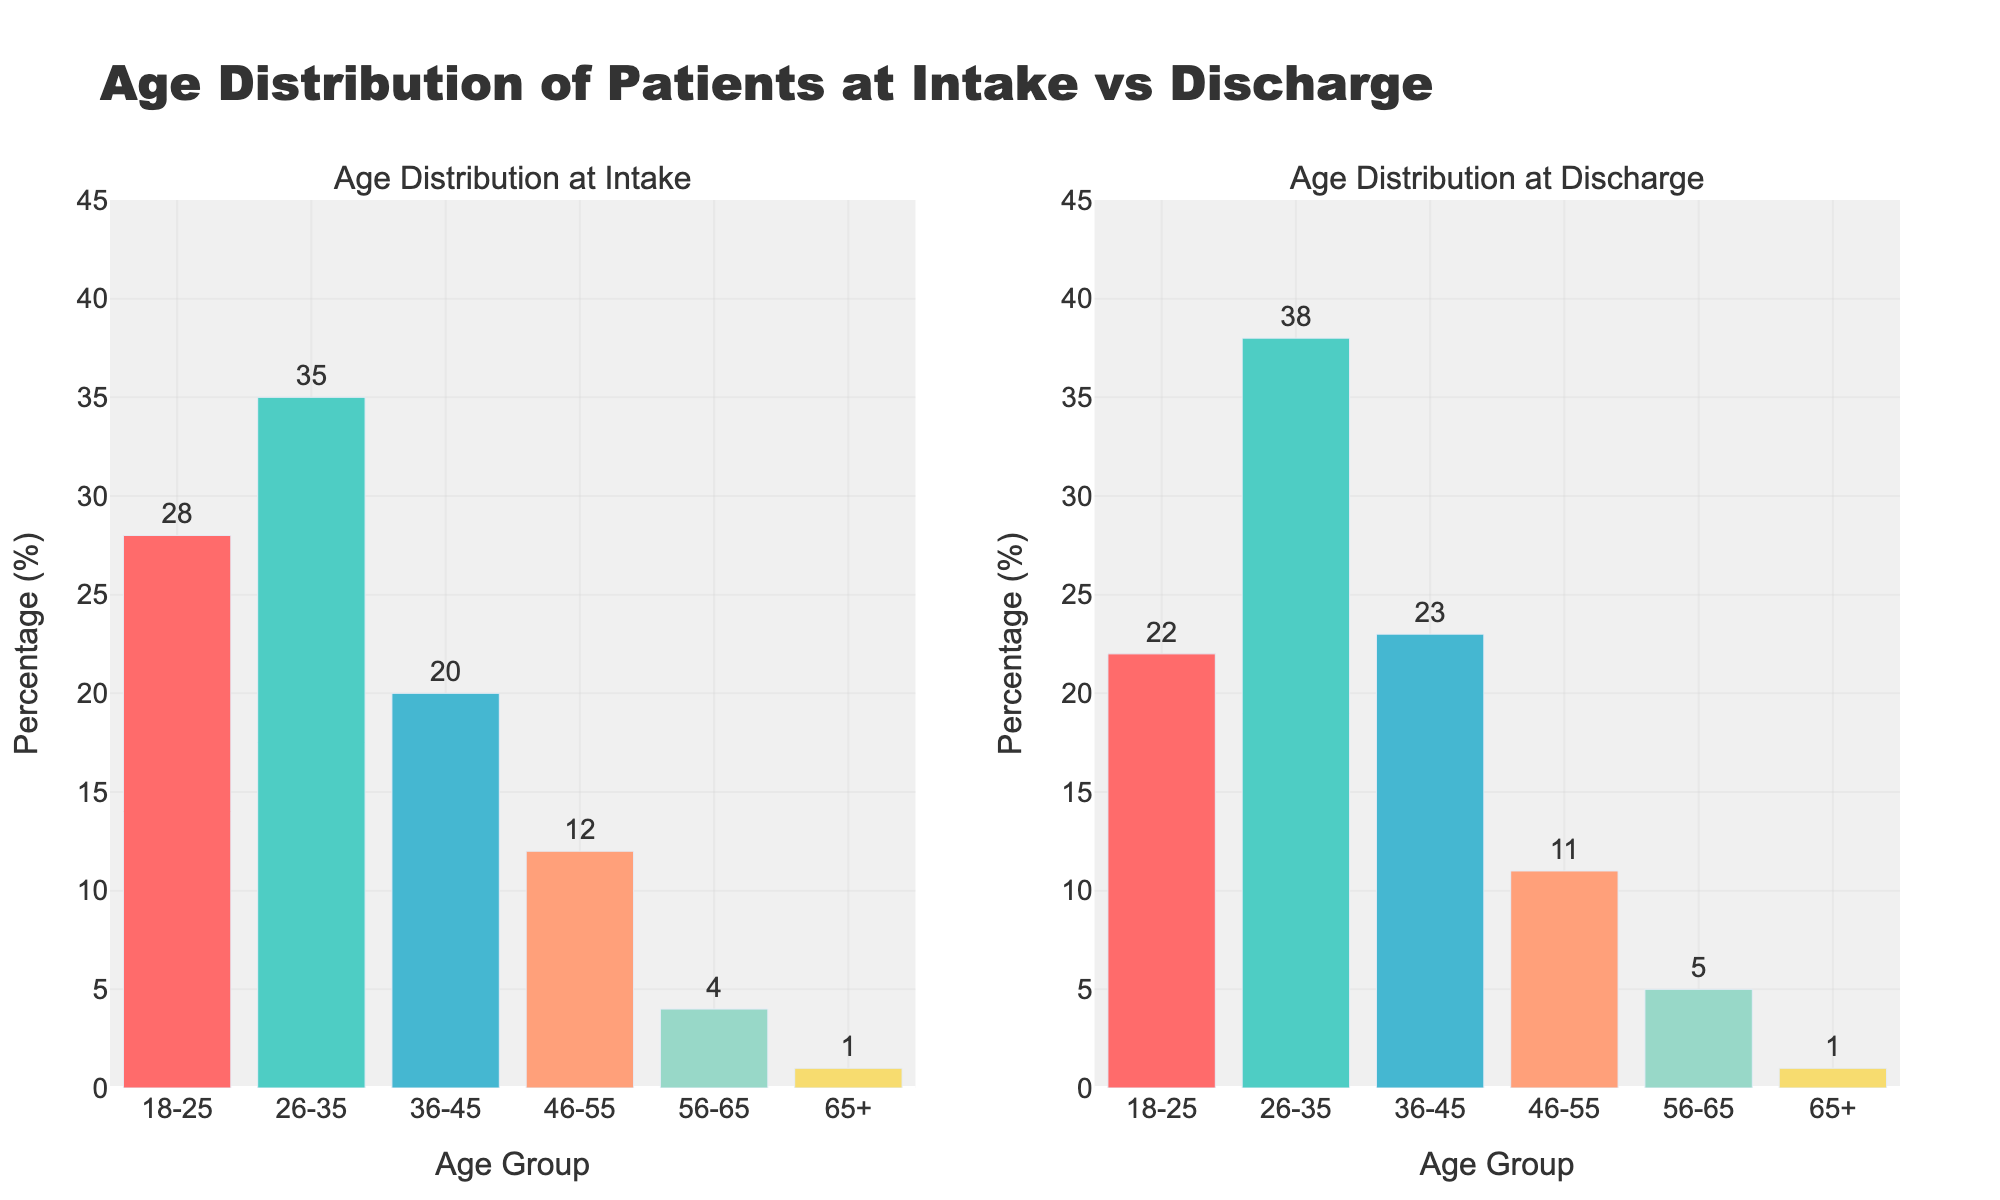What is the title of the figure? The title of the figure is given at the top of the plot. It is "Age Distribution of Patients at Intake vs Discharge".
Answer: Age Distribution of Patients at Intake vs Discharge Which age group has the highest percentage of patients at intake? Look at the bar for each age group in the first subplot and identify the one with the highest value. The age group 26-35 has the highest percentage with 35%.
Answer: 26-35 How much did the percentage of patients change for the age group 36-45 from intake to discharge? Subtract the intake percentage from the discharge percentage for the 36-45 age group. The change is 23% - 20% = 3%.
Answer: 3% Among the age groups 18-25 and 26-35, which age group saw an increase from intake to discharge? Compare the intake and discharge percentages for both age groups, finding that 18-25 decreased from 28% to 22%, while 26-35 increased from 35% to 38%.
Answer: 26-35 What is the common color used for the bars in both subplots? Observing the visual representation, all bars across age groups and both subplots use the same color palette consisting of six unique colors. The specific names of the colors are not needed, just the fact that they are consistent across subplots.
Answer: Same color palette Which age group saw no change in percentage from intake to discharge? Identify the age group where the intake and discharge percentages are equal. The age group 65+ has the same percentage at intake and discharge, both at 1%.
Answer: 65+ What is the total percentage of patients aged 46-55 across both intake and discharge periods? Add the percentages for intake and discharge for the age group 46-55: 12% (intake) + 11% (discharge) = 23%.
Answer: 23% Out of all age groups, which group had the smallest percentage change from intake to discharge? Compare the changes for each age group by calculating the absolute differences between intake and discharge percentages. The age group 65+ has the smallest change of 0% (1% - 1%).
Answer: 65+ How does the distribution of patients aged 56-65 compare at intake versus discharge? Compare the bar heights for the age group 56-65 in the two subplots. Both bars represent a 4% intake and a 5% discharge, showing a slight increase.
Answer: Slight increase Which age group had the largest decrease in the percentage of patients from intake to discharge? Calculate the decrease for each age group by subtracting discharge percentages from intake percentages and find the maximum. The age group 18-25 decreased the most, by 6% (28% - 22%).
Answer: 18-25 